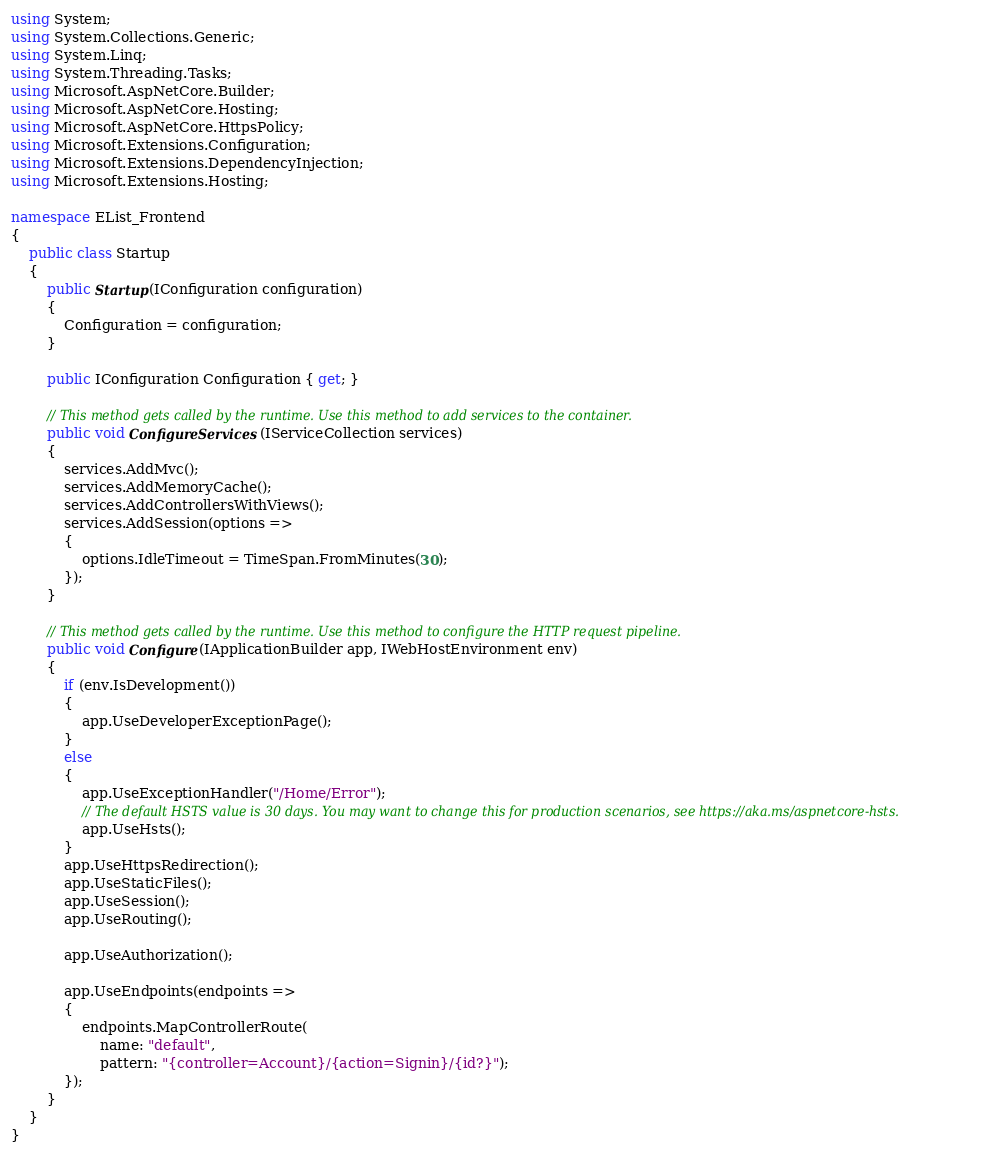<code> <loc_0><loc_0><loc_500><loc_500><_C#_>using System;
using System.Collections.Generic;
using System.Linq;
using System.Threading.Tasks;
using Microsoft.AspNetCore.Builder;
using Microsoft.AspNetCore.Hosting;
using Microsoft.AspNetCore.HttpsPolicy;
using Microsoft.Extensions.Configuration;
using Microsoft.Extensions.DependencyInjection;
using Microsoft.Extensions.Hosting;

namespace EList_Frontend
{
    public class Startup
    {
        public Startup(IConfiguration configuration)
        {
            Configuration = configuration;
        }

        public IConfiguration Configuration { get; }

        // This method gets called by the runtime. Use this method to add services to the container.
        public void ConfigureServices(IServiceCollection services)
        {
            services.AddMvc();
            services.AddMemoryCache();
            services.AddControllersWithViews();
            services.AddSession(options =>
            {
                options.IdleTimeout = TimeSpan.FromMinutes(30);
            });
        }

        // This method gets called by the runtime. Use this method to configure the HTTP request pipeline.
        public void Configure(IApplicationBuilder app, IWebHostEnvironment env)
        {
            if (env.IsDevelopment())
            {
                app.UseDeveloperExceptionPage();
            }
            else
            {
                app.UseExceptionHandler("/Home/Error");
                // The default HSTS value is 30 days. You may want to change this for production scenarios, see https://aka.ms/aspnetcore-hsts.
                app.UseHsts();
            }
            app.UseHttpsRedirection();
            app.UseStaticFiles();
            app.UseSession();
            app.UseRouting();

            app.UseAuthorization();

            app.UseEndpoints(endpoints =>
            {
                endpoints.MapControllerRoute(
                    name: "default",
                    pattern: "{controller=Account}/{action=Signin}/{id?}");
            });
        }
    }
}
</code> 